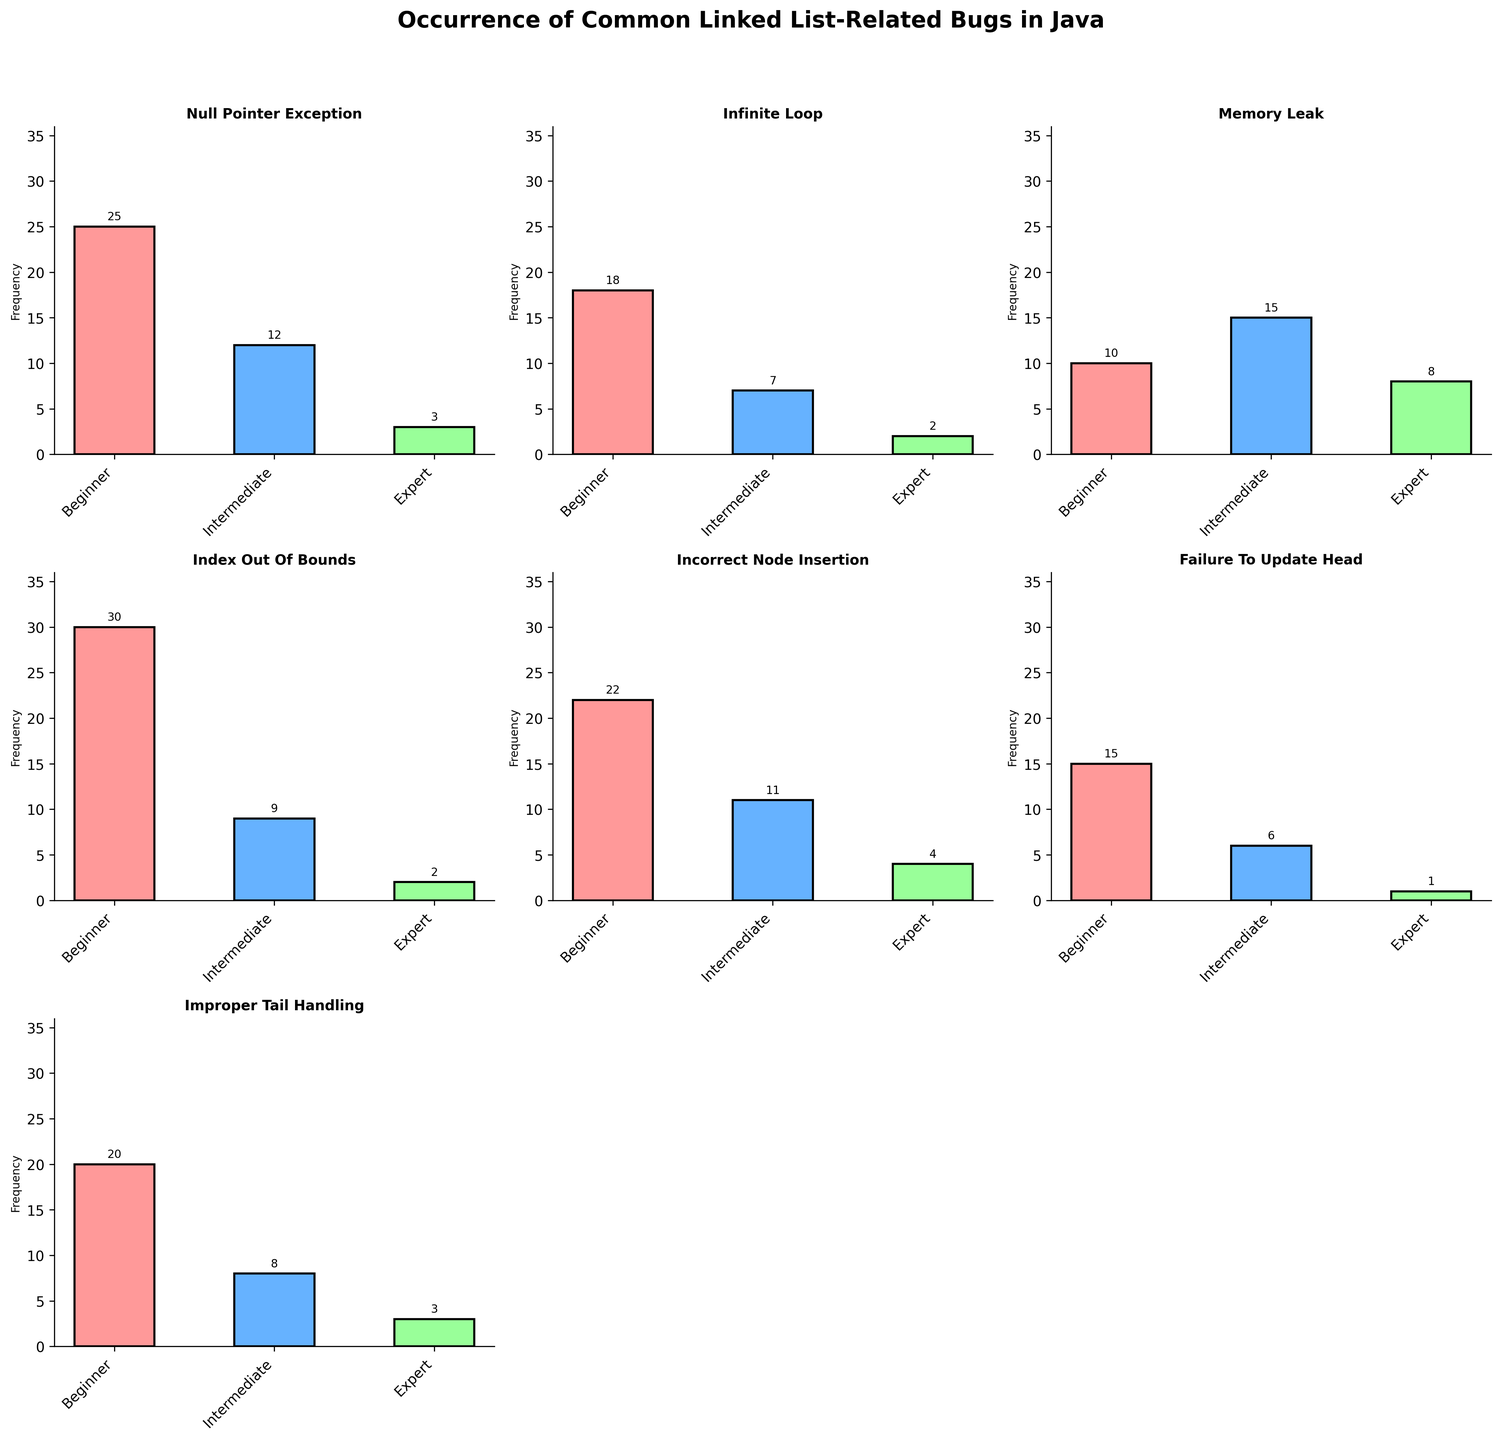What's the most common bug for beginner developers? First, we look at the bar plots for beginners across all subplots. The highest bar is found in the subplot for "Index Out Of Bounds" with a frequency of 30. Hence, "Index Out Of Bounds" is the most common bug.
Answer: Index Out Of Bounds How many times do experts encounter "Memory Leak"? Locate the "Memory Leak" subplot and find the bar corresponding to the "Expert" level. The frequency value indicated is 8.
Answer: 8 Which error type has the least frequency overall for expert developers? Compare the bars labeled "Expert" across all subplots. The "Failure To Update Head" has the lowest bar with a frequency of 1.
Answer: Failure To Update Head What's the total number of "Null Pointer Exception" occurrences across all experience levels? Locate the "Null Pointer Exception" subplot and sum up the values for all three experience levels: 25 (Beginner) + 12 (Intermediate) + 3 (Expert) = 40.
Answer: 40 Is the frequency of "Incorrect Node Insertion" higher for beginners or intermediate developers? In the "Incorrect Node Insertion" subplot, compare the bars for "Beginner" (22) and "Intermediate" (11). The "Beginner" value is larger.
Answer: Beginners What's the average frequency of "Improper Tail Handling" across all experience levels? Sum up the values in the "Improper Tail Handling" subplot: 20 (Beginner) + 8 (Intermediate) + 3 (Expert) = 31. Then divide this sum by the number of experience levels, 31/3 ≈ 10.33.
Answer: 10.33 How does the frequency of "Infinite Loop" for beginners compare to that for intermediate developers? In the "Infinite Loop" subplot, the frequency for beginners is 18 and for intermediates is 7. The beginners' frequency is higher.
Answer: Beginners What is the difference in frequency of "Index Out Of Bounds" errors between beginners and experts? The frequency of "Index Out Of Bounds" for beginners is 30 and for experts is 2. The difference is 30 - 2 = 28.
Answer: 28 What proportion of "Memory Leak" occurrences are from intermediate developers? In the "Memory Leak" subplot, the intermediate developers have a frequency of 15. The total frequency is 10 (Beginner) + 15 (Intermediate) + 8 (Expert) = 33. The proportion is 15/33 ≈ 0.454.
Answer: ~0.454 Which error type has the highest frequency for intermediate developers? Look at the "Intermediate" bars in each subplot. The highest value is 15 in the "Memory Leak" subplot.
Answer: Memory Leak 